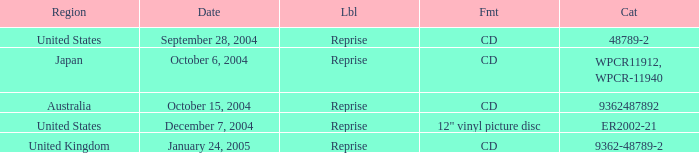Name the october 15, 2004 catalogue 9362487892.0. 